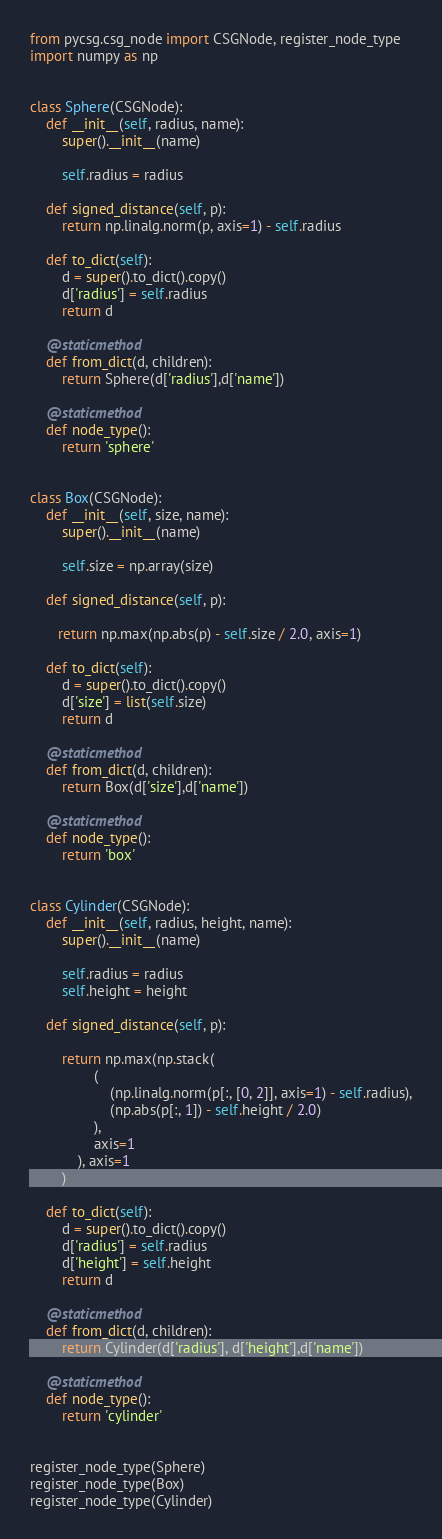<code> <loc_0><loc_0><loc_500><loc_500><_Python_>from pycsg.csg_node import CSGNode, register_node_type
import numpy as np


class Sphere(CSGNode):
    def __init__(self, radius, name):
        super().__init__(name)

        self.radius = radius

    def signed_distance(self, p):
        return np.linalg.norm(p, axis=1) - self.radius

    def to_dict(self):
        d = super().to_dict().copy()
        d['radius'] = self.radius
        return d

    @staticmethod
    def from_dict(d, children):
        return Sphere(d['radius'],d['name'])

    @staticmethod
    def node_type():
        return 'sphere'


class Box(CSGNode):
    def __init__(self, size, name):
        super().__init__(name)

        self.size = np.array(size)

    def signed_distance(self, p):

       return np.max(np.abs(p) - self.size / 2.0, axis=1)

    def to_dict(self):
        d = super().to_dict().copy()
        d['size'] = list(self.size)
        return d

    @staticmethod
    def from_dict(d, children):
        return Box(d['size'],d['name'])

    @staticmethod
    def node_type():
        return 'box'


class Cylinder(CSGNode):
    def __init__(self, radius, height, name):
        super().__init__(name)

        self.radius = radius
        self.height = height

    def signed_distance(self, p):

        return np.max(np.stack(
                (
                    (np.linalg.norm(p[:, [0, 2]], axis=1) - self.radius),
                    (np.abs(p[:, 1]) - self.height / 2.0)
                ),
                axis=1
            ), axis=1
        )

    def to_dict(self):
        d = super().to_dict().copy()
        d['radius'] = self.radius
        d['height'] = self.height
        return d

    @staticmethod
    def from_dict(d, children):
        return Cylinder(d['radius'], d['height'],d['name'])

    @staticmethod
    def node_type():
        return 'cylinder'


register_node_type(Sphere)
register_node_type(Box)
register_node_type(Cylinder)
</code> 